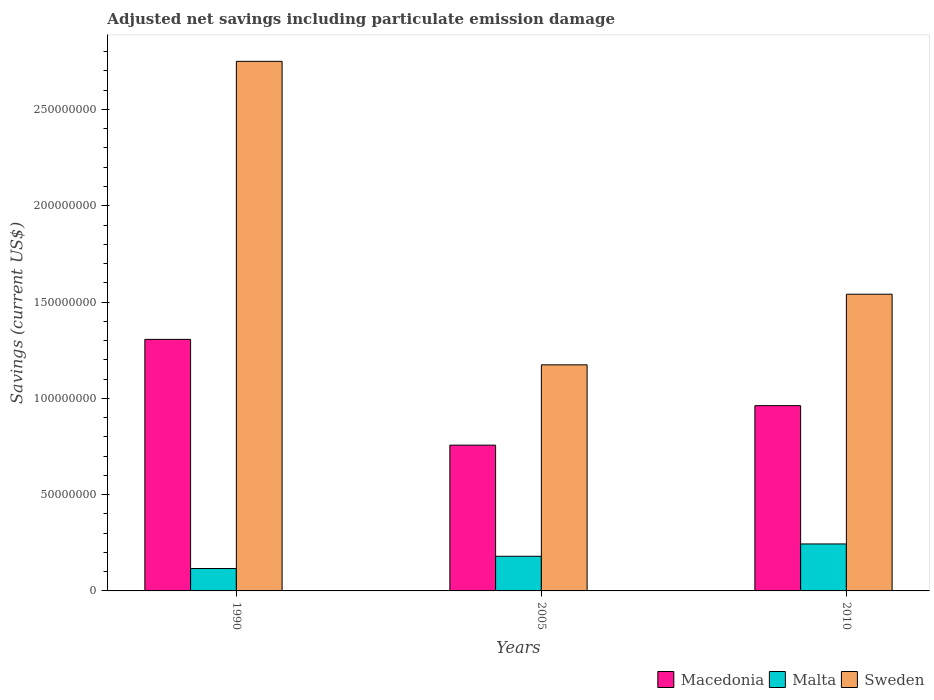How many groups of bars are there?
Offer a terse response. 3. How many bars are there on the 2nd tick from the right?
Give a very brief answer. 3. What is the label of the 3rd group of bars from the left?
Your answer should be compact. 2010. What is the net savings in Malta in 2005?
Your response must be concise. 1.80e+07. Across all years, what is the maximum net savings in Malta?
Provide a short and direct response. 2.44e+07. Across all years, what is the minimum net savings in Macedonia?
Provide a succinct answer. 7.57e+07. In which year was the net savings in Macedonia minimum?
Offer a very short reply. 2005. What is the total net savings in Sweden in the graph?
Keep it short and to the point. 5.46e+08. What is the difference between the net savings in Malta in 1990 and that in 2005?
Offer a terse response. -6.36e+06. What is the difference between the net savings in Macedonia in 2005 and the net savings in Sweden in 1990?
Provide a short and direct response. -1.99e+08. What is the average net savings in Macedonia per year?
Your answer should be compact. 1.01e+08. In the year 2010, what is the difference between the net savings in Sweden and net savings in Malta?
Offer a terse response. 1.30e+08. What is the ratio of the net savings in Sweden in 2005 to that in 2010?
Provide a short and direct response. 0.76. Is the difference between the net savings in Sweden in 1990 and 2010 greater than the difference between the net savings in Malta in 1990 and 2010?
Give a very brief answer. Yes. What is the difference between the highest and the second highest net savings in Macedonia?
Ensure brevity in your answer.  3.44e+07. What is the difference between the highest and the lowest net savings in Macedonia?
Offer a terse response. 5.49e+07. Is the sum of the net savings in Sweden in 2005 and 2010 greater than the maximum net savings in Malta across all years?
Give a very brief answer. Yes. What does the 1st bar from the left in 1990 represents?
Give a very brief answer. Macedonia. What does the 1st bar from the right in 2010 represents?
Make the answer very short. Sweden. How many years are there in the graph?
Make the answer very short. 3. What is the difference between two consecutive major ticks on the Y-axis?
Give a very brief answer. 5.00e+07. Are the values on the major ticks of Y-axis written in scientific E-notation?
Provide a short and direct response. No. Does the graph contain grids?
Provide a succinct answer. No. Where does the legend appear in the graph?
Keep it short and to the point. Bottom right. How many legend labels are there?
Offer a very short reply. 3. How are the legend labels stacked?
Offer a terse response. Horizontal. What is the title of the graph?
Your response must be concise. Adjusted net savings including particulate emission damage. Does "Sweden" appear as one of the legend labels in the graph?
Give a very brief answer. Yes. What is the label or title of the Y-axis?
Give a very brief answer. Savings (current US$). What is the Savings (current US$) of Macedonia in 1990?
Provide a succinct answer. 1.31e+08. What is the Savings (current US$) of Malta in 1990?
Offer a terse response. 1.16e+07. What is the Savings (current US$) in Sweden in 1990?
Ensure brevity in your answer.  2.75e+08. What is the Savings (current US$) in Macedonia in 2005?
Keep it short and to the point. 7.57e+07. What is the Savings (current US$) of Malta in 2005?
Your answer should be compact. 1.80e+07. What is the Savings (current US$) in Sweden in 2005?
Provide a short and direct response. 1.17e+08. What is the Savings (current US$) in Macedonia in 2010?
Keep it short and to the point. 9.62e+07. What is the Savings (current US$) in Malta in 2010?
Keep it short and to the point. 2.44e+07. What is the Savings (current US$) in Sweden in 2010?
Keep it short and to the point. 1.54e+08. Across all years, what is the maximum Savings (current US$) in Macedonia?
Provide a short and direct response. 1.31e+08. Across all years, what is the maximum Savings (current US$) of Malta?
Provide a short and direct response. 2.44e+07. Across all years, what is the maximum Savings (current US$) of Sweden?
Provide a short and direct response. 2.75e+08. Across all years, what is the minimum Savings (current US$) of Macedonia?
Provide a succinct answer. 7.57e+07. Across all years, what is the minimum Savings (current US$) of Malta?
Ensure brevity in your answer.  1.16e+07. Across all years, what is the minimum Savings (current US$) of Sweden?
Your answer should be compact. 1.17e+08. What is the total Savings (current US$) in Macedonia in the graph?
Your answer should be very brief. 3.03e+08. What is the total Savings (current US$) in Malta in the graph?
Keep it short and to the point. 5.40e+07. What is the total Savings (current US$) in Sweden in the graph?
Keep it short and to the point. 5.46e+08. What is the difference between the Savings (current US$) in Macedonia in 1990 and that in 2005?
Your answer should be compact. 5.49e+07. What is the difference between the Savings (current US$) in Malta in 1990 and that in 2005?
Ensure brevity in your answer.  -6.36e+06. What is the difference between the Savings (current US$) of Sweden in 1990 and that in 2005?
Give a very brief answer. 1.58e+08. What is the difference between the Savings (current US$) in Macedonia in 1990 and that in 2010?
Provide a succinct answer. 3.44e+07. What is the difference between the Savings (current US$) in Malta in 1990 and that in 2010?
Your answer should be very brief. -1.28e+07. What is the difference between the Savings (current US$) in Sweden in 1990 and that in 2010?
Keep it short and to the point. 1.21e+08. What is the difference between the Savings (current US$) of Macedonia in 2005 and that in 2010?
Provide a short and direct response. -2.05e+07. What is the difference between the Savings (current US$) of Malta in 2005 and that in 2010?
Provide a succinct answer. -6.40e+06. What is the difference between the Savings (current US$) in Sweden in 2005 and that in 2010?
Give a very brief answer. -3.67e+07. What is the difference between the Savings (current US$) in Macedonia in 1990 and the Savings (current US$) in Malta in 2005?
Your response must be concise. 1.13e+08. What is the difference between the Savings (current US$) of Macedonia in 1990 and the Savings (current US$) of Sweden in 2005?
Your answer should be compact. 1.32e+07. What is the difference between the Savings (current US$) in Malta in 1990 and the Savings (current US$) in Sweden in 2005?
Make the answer very short. -1.06e+08. What is the difference between the Savings (current US$) in Macedonia in 1990 and the Savings (current US$) in Malta in 2010?
Your answer should be compact. 1.06e+08. What is the difference between the Savings (current US$) of Macedonia in 1990 and the Savings (current US$) of Sweden in 2010?
Give a very brief answer. -2.34e+07. What is the difference between the Savings (current US$) in Malta in 1990 and the Savings (current US$) in Sweden in 2010?
Ensure brevity in your answer.  -1.42e+08. What is the difference between the Savings (current US$) of Macedonia in 2005 and the Savings (current US$) of Malta in 2010?
Offer a terse response. 5.13e+07. What is the difference between the Savings (current US$) of Macedonia in 2005 and the Savings (current US$) of Sweden in 2010?
Offer a very short reply. -7.84e+07. What is the difference between the Savings (current US$) of Malta in 2005 and the Savings (current US$) of Sweden in 2010?
Provide a short and direct response. -1.36e+08. What is the average Savings (current US$) of Macedonia per year?
Your response must be concise. 1.01e+08. What is the average Savings (current US$) of Malta per year?
Give a very brief answer. 1.80e+07. What is the average Savings (current US$) of Sweden per year?
Your response must be concise. 1.82e+08. In the year 1990, what is the difference between the Savings (current US$) of Macedonia and Savings (current US$) of Malta?
Give a very brief answer. 1.19e+08. In the year 1990, what is the difference between the Savings (current US$) of Macedonia and Savings (current US$) of Sweden?
Make the answer very short. -1.44e+08. In the year 1990, what is the difference between the Savings (current US$) of Malta and Savings (current US$) of Sweden?
Provide a short and direct response. -2.63e+08. In the year 2005, what is the difference between the Savings (current US$) of Macedonia and Savings (current US$) of Malta?
Offer a terse response. 5.77e+07. In the year 2005, what is the difference between the Savings (current US$) in Macedonia and Savings (current US$) in Sweden?
Offer a terse response. -4.17e+07. In the year 2005, what is the difference between the Savings (current US$) of Malta and Savings (current US$) of Sweden?
Offer a terse response. -9.94e+07. In the year 2010, what is the difference between the Savings (current US$) of Macedonia and Savings (current US$) of Malta?
Provide a succinct answer. 7.18e+07. In the year 2010, what is the difference between the Savings (current US$) in Macedonia and Savings (current US$) in Sweden?
Provide a succinct answer. -5.79e+07. In the year 2010, what is the difference between the Savings (current US$) in Malta and Savings (current US$) in Sweden?
Make the answer very short. -1.30e+08. What is the ratio of the Savings (current US$) of Macedonia in 1990 to that in 2005?
Provide a short and direct response. 1.73. What is the ratio of the Savings (current US$) in Malta in 1990 to that in 2005?
Your response must be concise. 0.65. What is the ratio of the Savings (current US$) of Sweden in 1990 to that in 2005?
Offer a terse response. 2.34. What is the ratio of the Savings (current US$) of Macedonia in 1990 to that in 2010?
Provide a succinct answer. 1.36. What is the ratio of the Savings (current US$) in Malta in 1990 to that in 2010?
Offer a terse response. 0.48. What is the ratio of the Savings (current US$) of Sweden in 1990 to that in 2010?
Give a very brief answer. 1.78. What is the ratio of the Savings (current US$) in Macedonia in 2005 to that in 2010?
Your response must be concise. 0.79. What is the ratio of the Savings (current US$) of Malta in 2005 to that in 2010?
Your answer should be compact. 0.74. What is the ratio of the Savings (current US$) of Sweden in 2005 to that in 2010?
Make the answer very short. 0.76. What is the difference between the highest and the second highest Savings (current US$) in Macedonia?
Keep it short and to the point. 3.44e+07. What is the difference between the highest and the second highest Savings (current US$) of Malta?
Provide a succinct answer. 6.40e+06. What is the difference between the highest and the second highest Savings (current US$) in Sweden?
Your response must be concise. 1.21e+08. What is the difference between the highest and the lowest Savings (current US$) in Macedonia?
Give a very brief answer. 5.49e+07. What is the difference between the highest and the lowest Savings (current US$) of Malta?
Ensure brevity in your answer.  1.28e+07. What is the difference between the highest and the lowest Savings (current US$) in Sweden?
Offer a very short reply. 1.58e+08. 